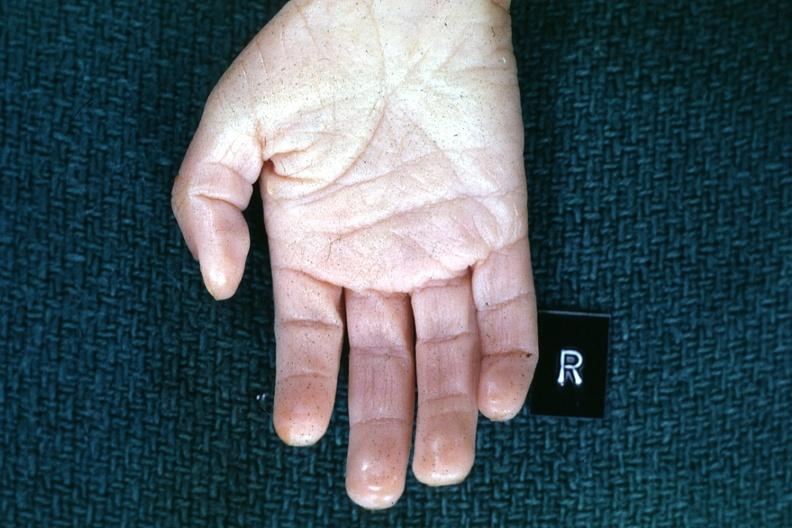re extremities present?
Answer the question using a single word or phrase. Yes 